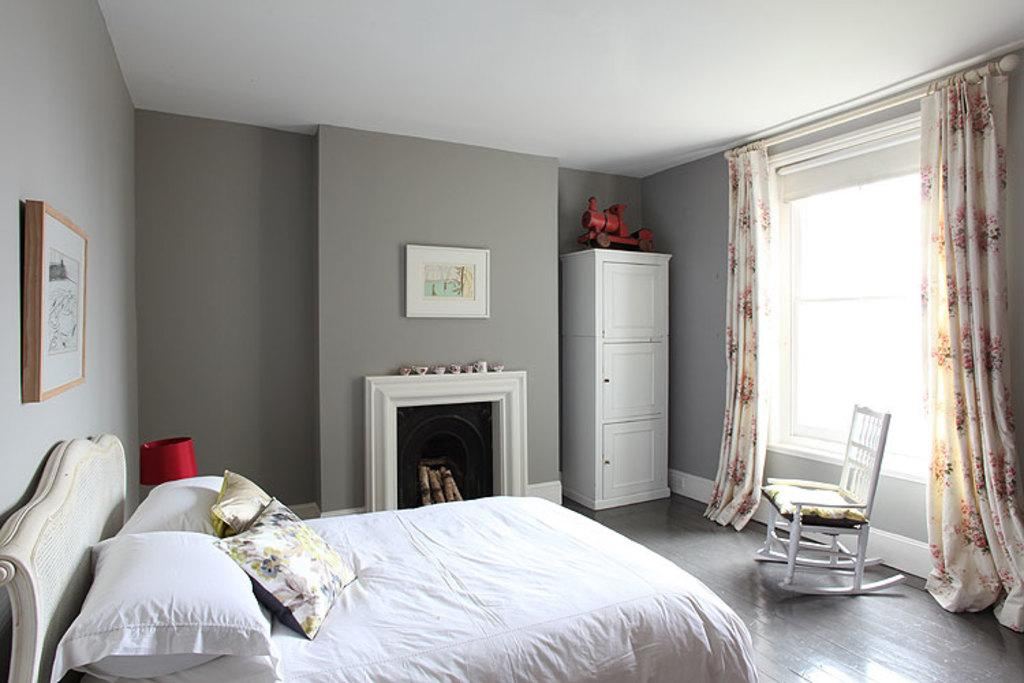What type of space is depicted in the image? There is a room in the image. What furniture is present in the room? There is a bed, a chair, and a wardrobe in the room. What can be found near the window in the room? There are curtains on the window in the room. Is there any decoration on the wall in the room? Yes, there is a photo frame on the wall in the room. How many apples are on the bed in the image? There are no apples present in the image; the bed is empty. What type of home is shown in the image? The image does not show a home; it only shows a room. 